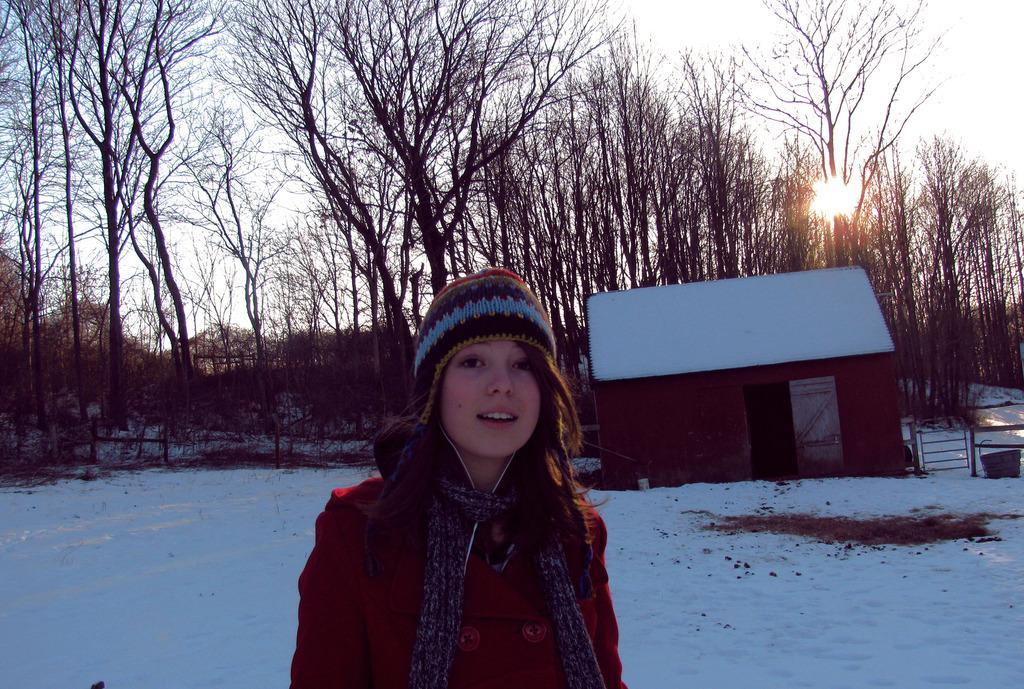Please provide a concise description of this image. In this picture we can see a woman wearing a cap and a scarf. There is the snow. We can see a house and a few rods on the right side. There are some trees visible in the background. 